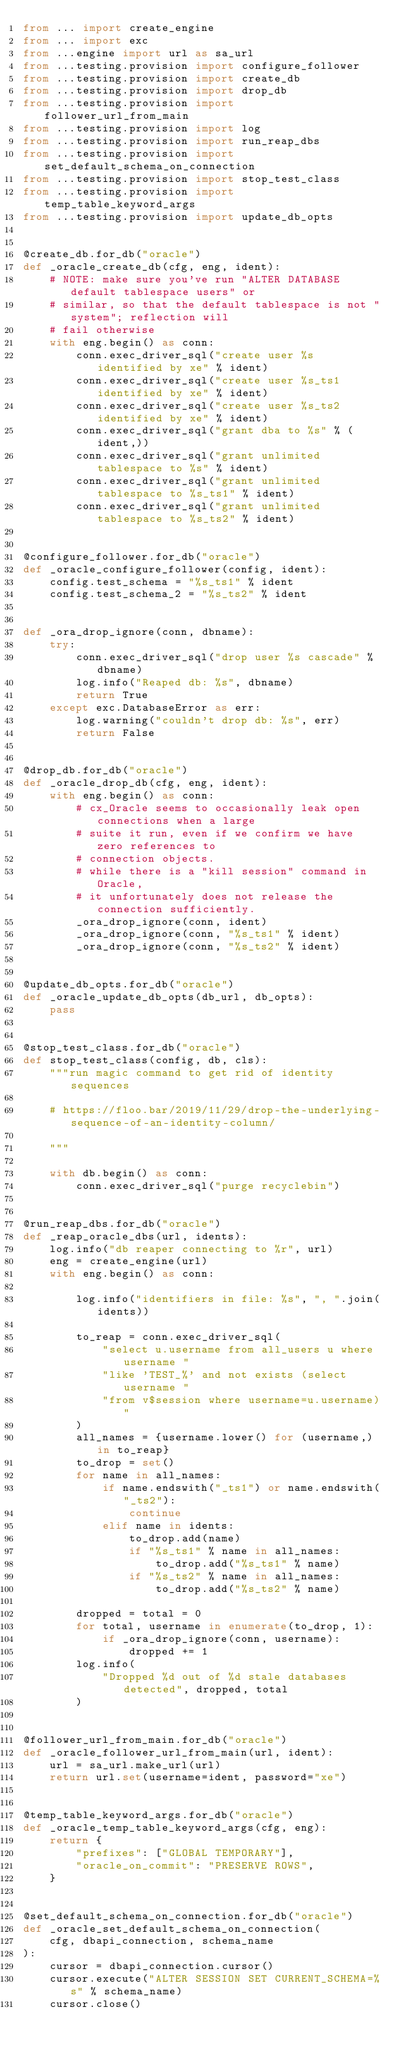<code> <loc_0><loc_0><loc_500><loc_500><_Python_>from ... import create_engine
from ... import exc
from ...engine import url as sa_url
from ...testing.provision import configure_follower
from ...testing.provision import create_db
from ...testing.provision import drop_db
from ...testing.provision import follower_url_from_main
from ...testing.provision import log
from ...testing.provision import run_reap_dbs
from ...testing.provision import set_default_schema_on_connection
from ...testing.provision import stop_test_class
from ...testing.provision import temp_table_keyword_args
from ...testing.provision import update_db_opts


@create_db.for_db("oracle")
def _oracle_create_db(cfg, eng, ident):
    # NOTE: make sure you've run "ALTER DATABASE default tablespace users" or
    # similar, so that the default tablespace is not "system"; reflection will
    # fail otherwise
    with eng.begin() as conn:
        conn.exec_driver_sql("create user %s identified by xe" % ident)
        conn.exec_driver_sql("create user %s_ts1 identified by xe" % ident)
        conn.exec_driver_sql("create user %s_ts2 identified by xe" % ident)
        conn.exec_driver_sql("grant dba to %s" % (ident,))
        conn.exec_driver_sql("grant unlimited tablespace to %s" % ident)
        conn.exec_driver_sql("grant unlimited tablespace to %s_ts1" % ident)
        conn.exec_driver_sql("grant unlimited tablespace to %s_ts2" % ident)


@configure_follower.for_db("oracle")
def _oracle_configure_follower(config, ident):
    config.test_schema = "%s_ts1" % ident
    config.test_schema_2 = "%s_ts2" % ident


def _ora_drop_ignore(conn, dbname):
    try:
        conn.exec_driver_sql("drop user %s cascade" % dbname)
        log.info("Reaped db: %s", dbname)
        return True
    except exc.DatabaseError as err:
        log.warning("couldn't drop db: %s", err)
        return False


@drop_db.for_db("oracle")
def _oracle_drop_db(cfg, eng, ident):
    with eng.begin() as conn:
        # cx_Oracle seems to occasionally leak open connections when a large
        # suite it run, even if we confirm we have zero references to
        # connection objects.
        # while there is a "kill session" command in Oracle,
        # it unfortunately does not release the connection sufficiently.
        _ora_drop_ignore(conn, ident)
        _ora_drop_ignore(conn, "%s_ts1" % ident)
        _ora_drop_ignore(conn, "%s_ts2" % ident)


@update_db_opts.for_db("oracle")
def _oracle_update_db_opts(db_url, db_opts):
    pass


@stop_test_class.for_db("oracle")
def stop_test_class(config, db, cls):
    """run magic command to get rid of identity sequences

    # https://floo.bar/2019/11/29/drop-the-underlying-sequence-of-an-identity-column/

    """

    with db.begin() as conn:
        conn.exec_driver_sql("purge recyclebin")


@run_reap_dbs.for_db("oracle")
def _reap_oracle_dbs(url, idents):
    log.info("db reaper connecting to %r", url)
    eng = create_engine(url)
    with eng.begin() as conn:

        log.info("identifiers in file: %s", ", ".join(idents))

        to_reap = conn.exec_driver_sql(
            "select u.username from all_users u where username "
            "like 'TEST_%' and not exists (select username "
            "from v$session where username=u.username)"
        )
        all_names = {username.lower() for (username,) in to_reap}
        to_drop = set()
        for name in all_names:
            if name.endswith("_ts1") or name.endswith("_ts2"):
                continue
            elif name in idents:
                to_drop.add(name)
                if "%s_ts1" % name in all_names:
                    to_drop.add("%s_ts1" % name)
                if "%s_ts2" % name in all_names:
                    to_drop.add("%s_ts2" % name)

        dropped = total = 0
        for total, username in enumerate(to_drop, 1):
            if _ora_drop_ignore(conn, username):
                dropped += 1
        log.info(
            "Dropped %d out of %d stale databases detected", dropped, total
        )


@follower_url_from_main.for_db("oracle")
def _oracle_follower_url_from_main(url, ident):
    url = sa_url.make_url(url)
    return url.set(username=ident, password="xe")


@temp_table_keyword_args.for_db("oracle")
def _oracle_temp_table_keyword_args(cfg, eng):
    return {
        "prefixes": ["GLOBAL TEMPORARY"],
        "oracle_on_commit": "PRESERVE ROWS",
    }


@set_default_schema_on_connection.for_db("oracle")
def _oracle_set_default_schema_on_connection(
    cfg, dbapi_connection, schema_name
):
    cursor = dbapi_connection.cursor()
    cursor.execute("ALTER SESSION SET CURRENT_SCHEMA=%s" % schema_name)
    cursor.close()
</code> 